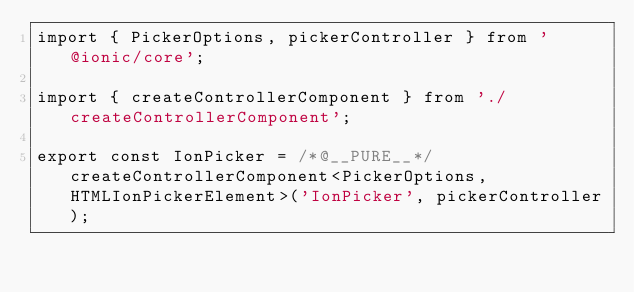Convert code to text. <code><loc_0><loc_0><loc_500><loc_500><_TypeScript_>import { PickerOptions, pickerController } from '@ionic/core';

import { createControllerComponent } from './createControllerComponent';

export const IonPicker = /*@__PURE__*/createControllerComponent<PickerOptions, HTMLIonPickerElement>('IonPicker', pickerController);
</code> 